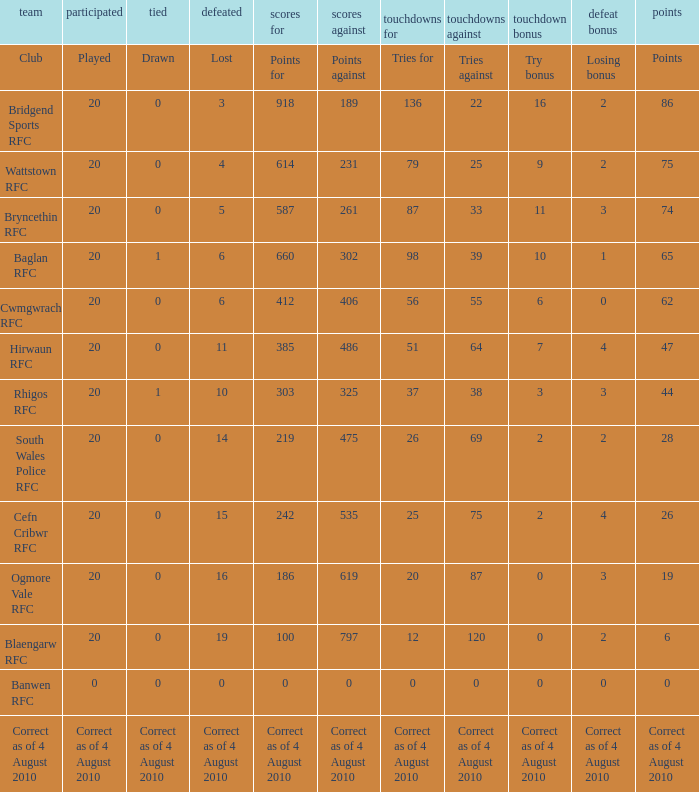Could you parse the entire table? {'header': ['team', 'participated', 'tied', 'defeated', 'scores for', 'scores against', 'touchdowns for', 'touchdowns against', 'touchdown bonus', 'defeat bonus', 'points'], 'rows': [['Club', 'Played', 'Drawn', 'Lost', 'Points for', 'Points against', 'Tries for', 'Tries against', 'Try bonus', 'Losing bonus', 'Points'], ['Bridgend Sports RFC', '20', '0', '3', '918', '189', '136', '22', '16', '2', '86'], ['Wattstown RFC', '20', '0', '4', '614', '231', '79', '25', '9', '2', '75'], ['Bryncethin RFC', '20', '0', '5', '587', '261', '87', '33', '11', '3', '74'], ['Baglan RFC', '20', '1', '6', '660', '302', '98', '39', '10', '1', '65'], ['Cwmgwrach RFC', '20', '0', '6', '412', '406', '56', '55', '6', '0', '62'], ['Hirwaun RFC', '20', '0', '11', '385', '486', '51', '64', '7', '4', '47'], ['Rhigos RFC', '20', '1', '10', '303', '325', '37', '38', '3', '3', '44'], ['South Wales Police RFC', '20', '0', '14', '219', '475', '26', '69', '2', '2', '28'], ['Cefn Cribwr RFC', '20', '0', '15', '242', '535', '25', '75', '2', '4', '26'], ['Ogmore Vale RFC', '20', '0', '16', '186', '619', '20', '87', '0', '3', '19'], ['Blaengarw RFC', '20', '0', '19', '100', '797', '12', '120', '0', '2', '6'], ['Banwen RFC', '0', '0', '0', '0', '0', '0', '0', '0', '0', '0'], ['Correct as of 4 August 2010', 'Correct as of 4 August 2010', 'Correct as of 4 August 2010', 'Correct as of 4 August 2010', 'Correct as of 4 August 2010', 'Correct as of 4 August 2010', 'Correct as of 4 August 2010', 'Correct as of 4 August 2010', 'Correct as of 4 August 2010', 'Correct as of 4 August 2010', 'Correct as of 4 August 2010']]} When the club is hirwaun rfc, what is illustrated? 0.0. 